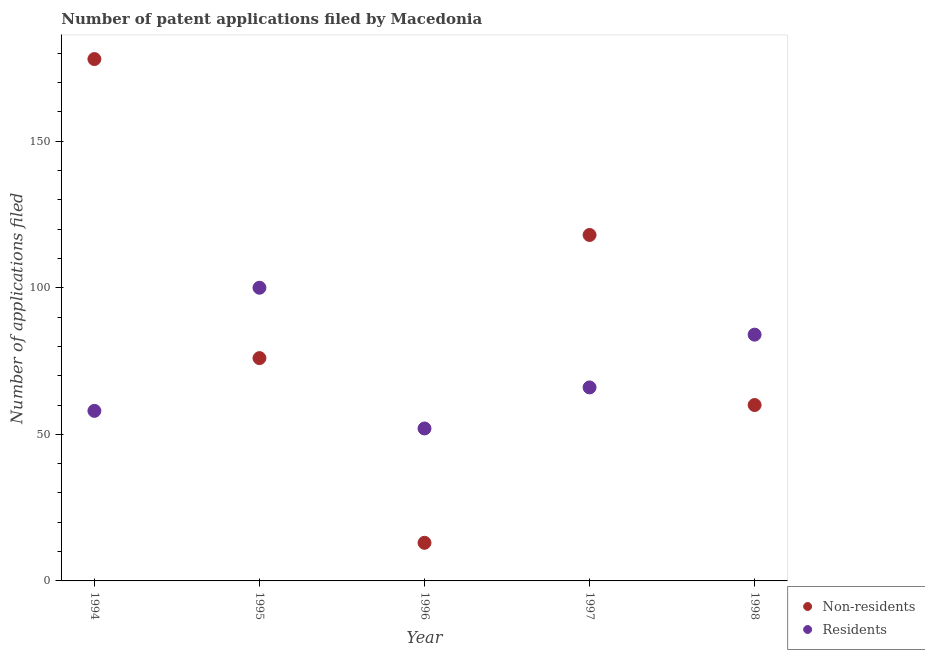How many different coloured dotlines are there?
Keep it short and to the point. 2. Is the number of dotlines equal to the number of legend labels?
Offer a very short reply. Yes. What is the number of patent applications by residents in 1998?
Ensure brevity in your answer.  84. Across all years, what is the maximum number of patent applications by residents?
Make the answer very short. 100. Across all years, what is the minimum number of patent applications by residents?
Make the answer very short. 52. What is the total number of patent applications by non residents in the graph?
Provide a succinct answer. 445. What is the difference between the number of patent applications by residents in 1995 and that in 1998?
Your answer should be very brief. 16. What is the difference between the number of patent applications by residents in 1997 and the number of patent applications by non residents in 1996?
Make the answer very short. 53. What is the average number of patent applications by non residents per year?
Provide a succinct answer. 89. In the year 1998, what is the difference between the number of patent applications by residents and number of patent applications by non residents?
Provide a short and direct response. 24. In how many years, is the number of patent applications by non residents greater than 140?
Provide a short and direct response. 1. What is the ratio of the number of patent applications by residents in 1994 to that in 1997?
Make the answer very short. 0.88. Is the number of patent applications by residents in 1994 less than that in 1998?
Make the answer very short. Yes. Is the difference between the number of patent applications by residents in 1994 and 1995 greater than the difference between the number of patent applications by non residents in 1994 and 1995?
Provide a succinct answer. No. What is the difference between the highest and the second highest number of patent applications by residents?
Ensure brevity in your answer.  16. What is the difference between the highest and the lowest number of patent applications by residents?
Your answer should be very brief. 48. In how many years, is the number of patent applications by residents greater than the average number of patent applications by residents taken over all years?
Provide a short and direct response. 2. Is the sum of the number of patent applications by residents in 1995 and 1998 greater than the maximum number of patent applications by non residents across all years?
Your response must be concise. Yes. Is the number of patent applications by residents strictly greater than the number of patent applications by non residents over the years?
Make the answer very short. No. Is the number of patent applications by residents strictly less than the number of patent applications by non residents over the years?
Provide a succinct answer. No. How many dotlines are there?
Your answer should be very brief. 2. How many years are there in the graph?
Make the answer very short. 5. Does the graph contain any zero values?
Offer a very short reply. No. Where does the legend appear in the graph?
Offer a terse response. Bottom right. How many legend labels are there?
Your answer should be compact. 2. What is the title of the graph?
Provide a succinct answer. Number of patent applications filed by Macedonia. Does "Arms imports" appear as one of the legend labels in the graph?
Your answer should be compact. No. What is the label or title of the X-axis?
Offer a terse response. Year. What is the label or title of the Y-axis?
Your response must be concise. Number of applications filed. What is the Number of applications filed of Non-residents in 1994?
Your response must be concise. 178. What is the Number of applications filed of Residents in 1995?
Provide a succinct answer. 100. What is the Number of applications filed in Non-residents in 1996?
Make the answer very short. 13. What is the Number of applications filed in Non-residents in 1997?
Give a very brief answer. 118. What is the Number of applications filed of Residents in 1997?
Keep it short and to the point. 66. What is the Number of applications filed of Residents in 1998?
Offer a very short reply. 84. Across all years, what is the maximum Number of applications filed of Non-residents?
Your response must be concise. 178. What is the total Number of applications filed of Non-residents in the graph?
Offer a very short reply. 445. What is the total Number of applications filed of Residents in the graph?
Offer a very short reply. 360. What is the difference between the Number of applications filed of Non-residents in 1994 and that in 1995?
Your answer should be compact. 102. What is the difference between the Number of applications filed in Residents in 1994 and that in 1995?
Provide a short and direct response. -42. What is the difference between the Number of applications filed in Non-residents in 1994 and that in 1996?
Give a very brief answer. 165. What is the difference between the Number of applications filed in Residents in 1994 and that in 1996?
Keep it short and to the point. 6. What is the difference between the Number of applications filed in Non-residents in 1994 and that in 1998?
Provide a short and direct response. 118. What is the difference between the Number of applications filed in Residents in 1994 and that in 1998?
Provide a short and direct response. -26. What is the difference between the Number of applications filed in Non-residents in 1995 and that in 1996?
Offer a terse response. 63. What is the difference between the Number of applications filed in Non-residents in 1995 and that in 1997?
Provide a succinct answer. -42. What is the difference between the Number of applications filed in Residents in 1995 and that in 1997?
Provide a succinct answer. 34. What is the difference between the Number of applications filed in Residents in 1995 and that in 1998?
Offer a very short reply. 16. What is the difference between the Number of applications filed of Non-residents in 1996 and that in 1997?
Provide a succinct answer. -105. What is the difference between the Number of applications filed of Residents in 1996 and that in 1997?
Your answer should be very brief. -14. What is the difference between the Number of applications filed in Non-residents in 1996 and that in 1998?
Give a very brief answer. -47. What is the difference between the Number of applications filed in Residents in 1996 and that in 1998?
Provide a succinct answer. -32. What is the difference between the Number of applications filed in Non-residents in 1997 and that in 1998?
Your response must be concise. 58. What is the difference between the Number of applications filed in Residents in 1997 and that in 1998?
Make the answer very short. -18. What is the difference between the Number of applications filed of Non-residents in 1994 and the Number of applications filed of Residents in 1996?
Provide a succinct answer. 126. What is the difference between the Number of applications filed in Non-residents in 1994 and the Number of applications filed in Residents in 1997?
Provide a short and direct response. 112. What is the difference between the Number of applications filed of Non-residents in 1994 and the Number of applications filed of Residents in 1998?
Keep it short and to the point. 94. What is the difference between the Number of applications filed of Non-residents in 1995 and the Number of applications filed of Residents in 1996?
Make the answer very short. 24. What is the difference between the Number of applications filed in Non-residents in 1996 and the Number of applications filed in Residents in 1997?
Your answer should be compact. -53. What is the difference between the Number of applications filed of Non-residents in 1996 and the Number of applications filed of Residents in 1998?
Your answer should be compact. -71. What is the difference between the Number of applications filed of Non-residents in 1997 and the Number of applications filed of Residents in 1998?
Offer a very short reply. 34. What is the average Number of applications filed in Non-residents per year?
Make the answer very short. 89. What is the average Number of applications filed of Residents per year?
Your response must be concise. 72. In the year 1994, what is the difference between the Number of applications filed in Non-residents and Number of applications filed in Residents?
Offer a very short reply. 120. In the year 1995, what is the difference between the Number of applications filed in Non-residents and Number of applications filed in Residents?
Provide a short and direct response. -24. In the year 1996, what is the difference between the Number of applications filed in Non-residents and Number of applications filed in Residents?
Your response must be concise. -39. What is the ratio of the Number of applications filed in Non-residents in 1994 to that in 1995?
Offer a very short reply. 2.34. What is the ratio of the Number of applications filed in Residents in 1994 to that in 1995?
Provide a succinct answer. 0.58. What is the ratio of the Number of applications filed in Non-residents in 1994 to that in 1996?
Give a very brief answer. 13.69. What is the ratio of the Number of applications filed of Residents in 1994 to that in 1996?
Offer a very short reply. 1.12. What is the ratio of the Number of applications filed in Non-residents in 1994 to that in 1997?
Your answer should be very brief. 1.51. What is the ratio of the Number of applications filed in Residents in 1994 to that in 1997?
Your response must be concise. 0.88. What is the ratio of the Number of applications filed of Non-residents in 1994 to that in 1998?
Ensure brevity in your answer.  2.97. What is the ratio of the Number of applications filed of Residents in 1994 to that in 1998?
Give a very brief answer. 0.69. What is the ratio of the Number of applications filed in Non-residents in 1995 to that in 1996?
Make the answer very short. 5.85. What is the ratio of the Number of applications filed of Residents in 1995 to that in 1996?
Offer a very short reply. 1.92. What is the ratio of the Number of applications filed of Non-residents in 1995 to that in 1997?
Your answer should be compact. 0.64. What is the ratio of the Number of applications filed in Residents in 1995 to that in 1997?
Provide a short and direct response. 1.52. What is the ratio of the Number of applications filed of Non-residents in 1995 to that in 1998?
Make the answer very short. 1.27. What is the ratio of the Number of applications filed in Residents in 1995 to that in 1998?
Give a very brief answer. 1.19. What is the ratio of the Number of applications filed in Non-residents in 1996 to that in 1997?
Give a very brief answer. 0.11. What is the ratio of the Number of applications filed in Residents in 1996 to that in 1997?
Provide a succinct answer. 0.79. What is the ratio of the Number of applications filed of Non-residents in 1996 to that in 1998?
Ensure brevity in your answer.  0.22. What is the ratio of the Number of applications filed in Residents in 1996 to that in 1998?
Provide a succinct answer. 0.62. What is the ratio of the Number of applications filed of Non-residents in 1997 to that in 1998?
Offer a terse response. 1.97. What is the ratio of the Number of applications filed in Residents in 1997 to that in 1998?
Offer a terse response. 0.79. What is the difference between the highest and the lowest Number of applications filed of Non-residents?
Offer a very short reply. 165. What is the difference between the highest and the lowest Number of applications filed of Residents?
Your response must be concise. 48. 